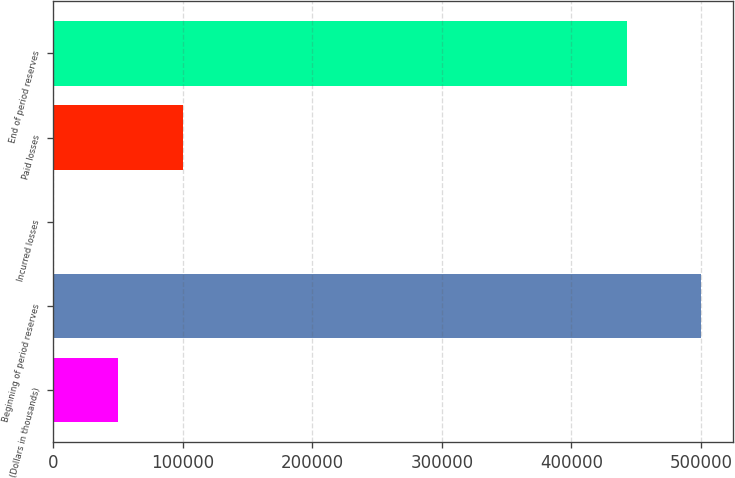Convert chart to OTSL. <chart><loc_0><loc_0><loc_500><loc_500><bar_chart><fcel>(Dollars in thousands)<fcel>Beginning of period reserves<fcel>Incurred losses<fcel>Paid losses<fcel>End of period reserves<nl><fcel>50109.9<fcel>499911<fcel>132<fcel>100088<fcel>442821<nl></chart> 